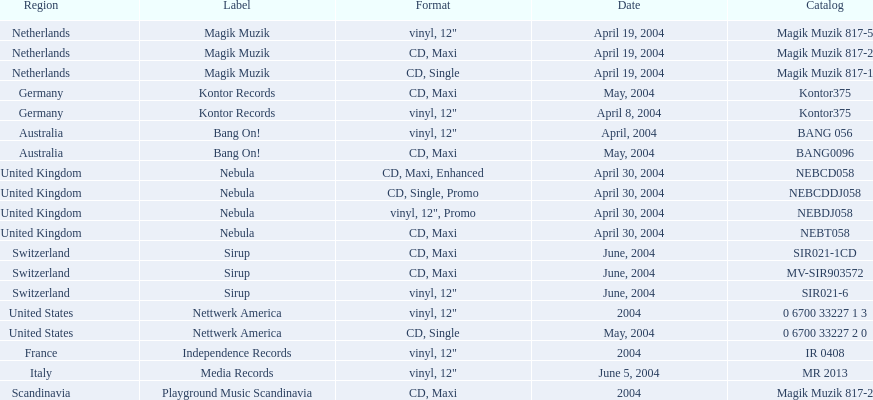What are the labels for love comes again? Magik Muzik, Magik Muzik, Magik Muzik, Kontor Records, Kontor Records, Bang On!, Bang On!, Nebula, Nebula, Nebula, Nebula, Sirup, Sirup, Sirup, Nettwerk America, Nettwerk America, Independence Records, Media Records, Playground Music Scandinavia. What label has been used by the region of france? Independence Records. 